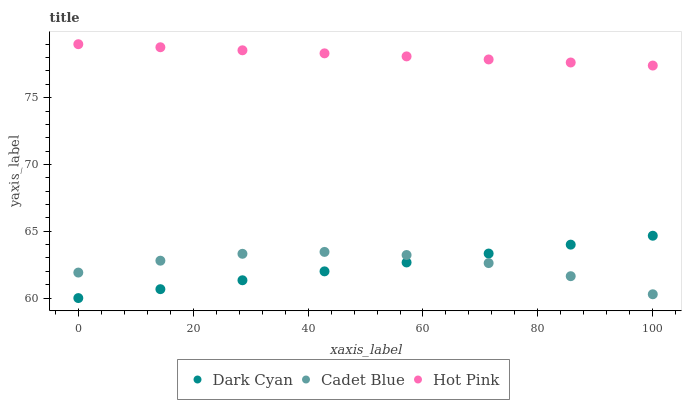Does Dark Cyan have the minimum area under the curve?
Answer yes or no. Yes. Does Hot Pink have the maximum area under the curve?
Answer yes or no. Yes. Does Cadet Blue have the minimum area under the curve?
Answer yes or no. No. Does Cadet Blue have the maximum area under the curve?
Answer yes or no. No. Is Hot Pink the smoothest?
Answer yes or no. Yes. Is Cadet Blue the roughest?
Answer yes or no. Yes. Is Cadet Blue the smoothest?
Answer yes or no. No. Is Hot Pink the roughest?
Answer yes or no. No. Does Dark Cyan have the lowest value?
Answer yes or no. Yes. Does Cadet Blue have the lowest value?
Answer yes or no. No. Does Hot Pink have the highest value?
Answer yes or no. Yes. Does Cadet Blue have the highest value?
Answer yes or no. No. Is Dark Cyan less than Hot Pink?
Answer yes or no. Yes. Is Hot Pink greater than Dark Cyan?
Answer yes or no. Yes. Does Dark Cyan intersect Cadet Blue?
Answer yes or no. Yes. Is Dark Cyan less than Cadet Blue?
Answer yes or no. No. Is Dark Cyan greater than Cadet Blue?
Answer yes or no. No. Does Dark Cyan intersect Hot Pink?
Answer yes or no. No. 